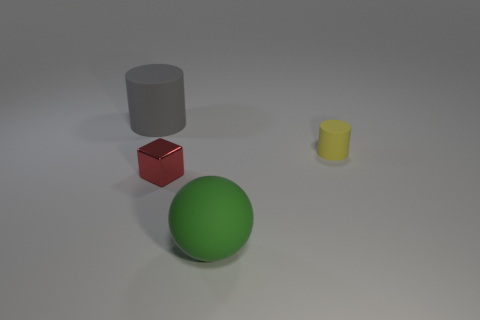Add 1 small metallic cubes. How many objects exist? 5 Subtract all blocks. How many objects are left? 3 Add 2 large gray cylinders. How many large gray cylinders are left? 3 Add 4 large gray matte things. How many large gray matte things exist? 5 Subtract 0 yellow balls. How many objects are left? 4 Subtract all gray cylinders. Subtract all small shiny blocks. How many objects are left? 2 